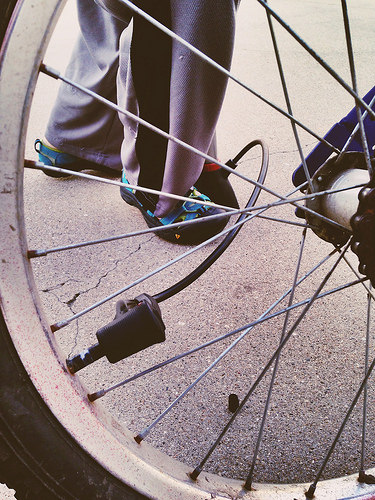<image>
Is there a cycle pump next to the shoes? Yes. The cycle pump is positioned adjacent to the shoes, located nearby in the same general area. 